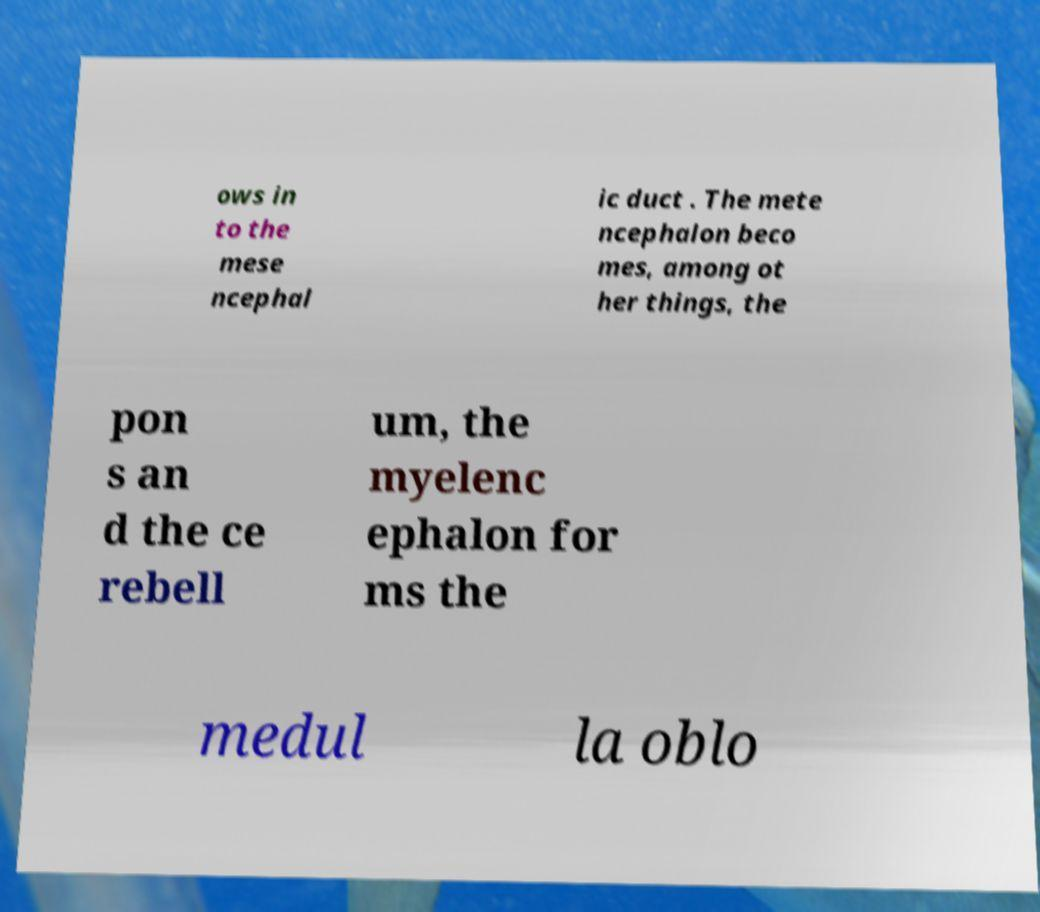Could you extract and type out the text from this image? ows in to the mese ncephal ic duct . The mete ncephalon beco mes, among ot her things, the pon s an d the ce rebell um, the myelenc ephalon for ms the medul la oblo 